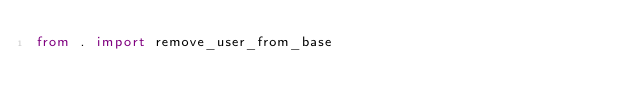Convert code to text. <code><loc_0><loc_0><loc_500><loc_500><_Python_>from . import remove_user_from_base</code> 